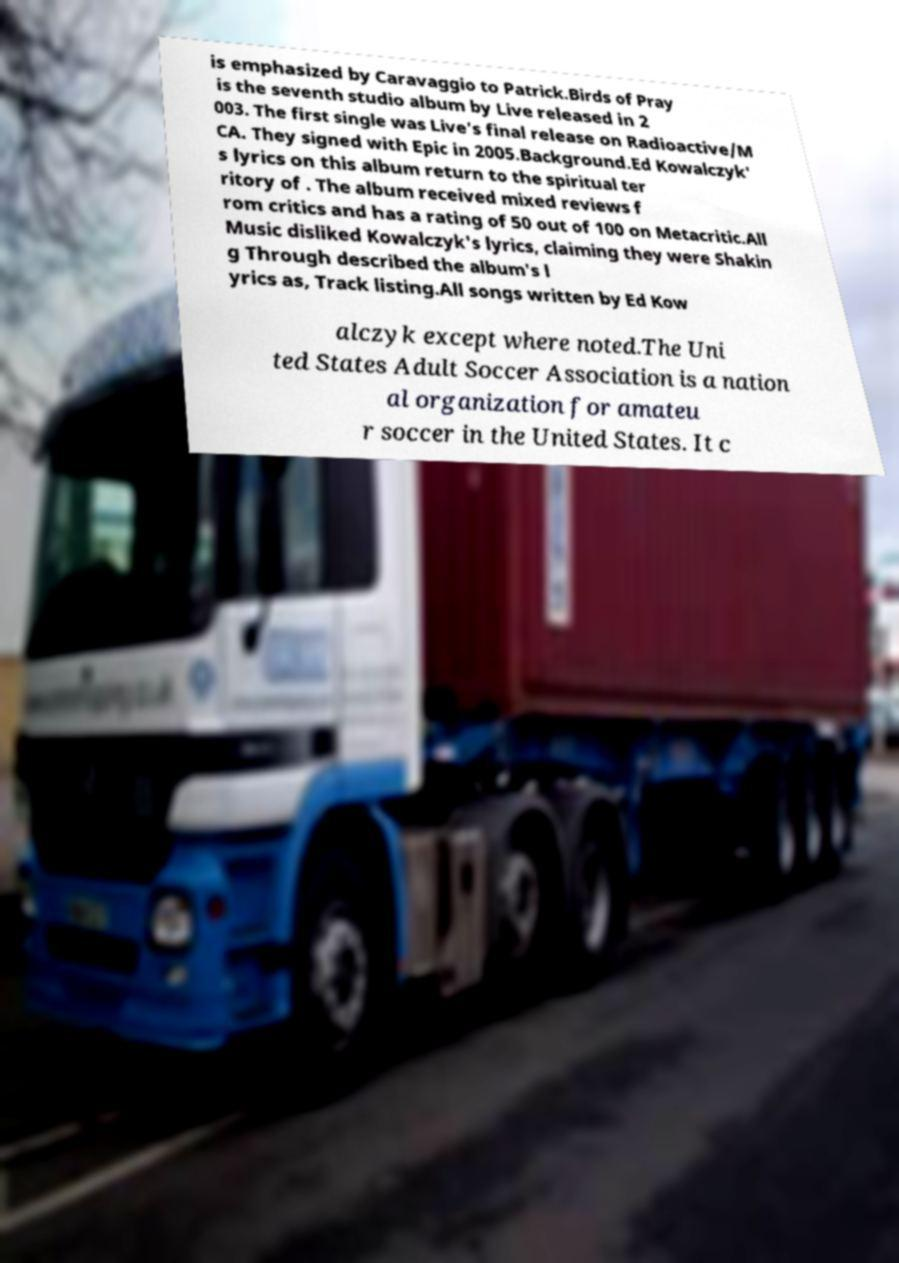Please identify and transcribe the text found in this image. is emphasized by Caravaggio to Patrick.Birds of Pray is the seventh studio album by Live released in 2 003. The first single was Live's final release on Radioactive/M CA. They signed with Epic in 2005.Background.Ed Kowalczyk' s lyrics on this album return to the spiritual ter ritory of . The album received mixed reviews f rom critics and has a rating of 50 out of 100 on Metacritic.All Music disliked Kowalczyk's lyrics, claiming they were Shakin g Through described the album's l yrics as, Track listing.All songs written by Ed Kow alczyk except where noted.The Uni ted States Adult Soccer Association is a nation al organization for amateu r soccer in the United States. It c 